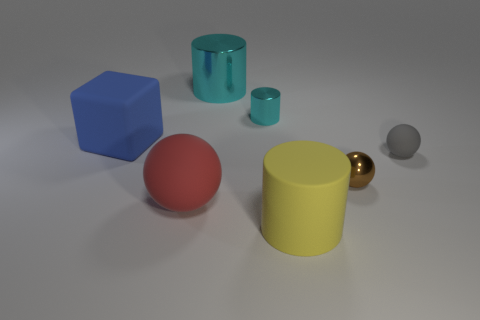Is the number of small cylinders less than the number of small green rubber objects?
Keep it short and to the point. No. How many other things are made of the same material as the big blue block?
Keep it short and to the point. 3. There is a red object that is the same shape as the tiny gray matte thing; what size is it?
Offer a terse response. Large. Is the tiny object that is behind the blue rubber block made of the same material as the sphere that is behind the tiny brown metal sphere?
Make the answer very short. No. Is the number of small cyan shiny objects to the left of the blue block less than the number of tiny gray objects?
Your answer should be compact. Yes. Is there anything else that is the same shape as the blue object?
Ensure brevity in your answer.  No. There is a small metallic object that is the same shape as the red rubber object; what color is it?
Make the answer very short. Brown. Do the object on the right side of the metal sphere and the large cyan metallic cylinder have the same size?
Make the answer very short. No. How big is the cylinder that is on the right side of the small metallic object that is behind the big blue rubber thing?
Your response must be concise. Large. Is the small cyan cylinder made of the same material as the big cylinder that is in front of the big metallic thing?
Give a very brief answer. No. 